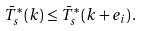<formula> <loc_0><loc_0><loc_500><loc_500>\bar { T } _ { s } ^ { * } \left ( k \right ) \leq \bar { T } _ { s } ^ { * } \left ( k + e _ { i } \right ) .</formula> 